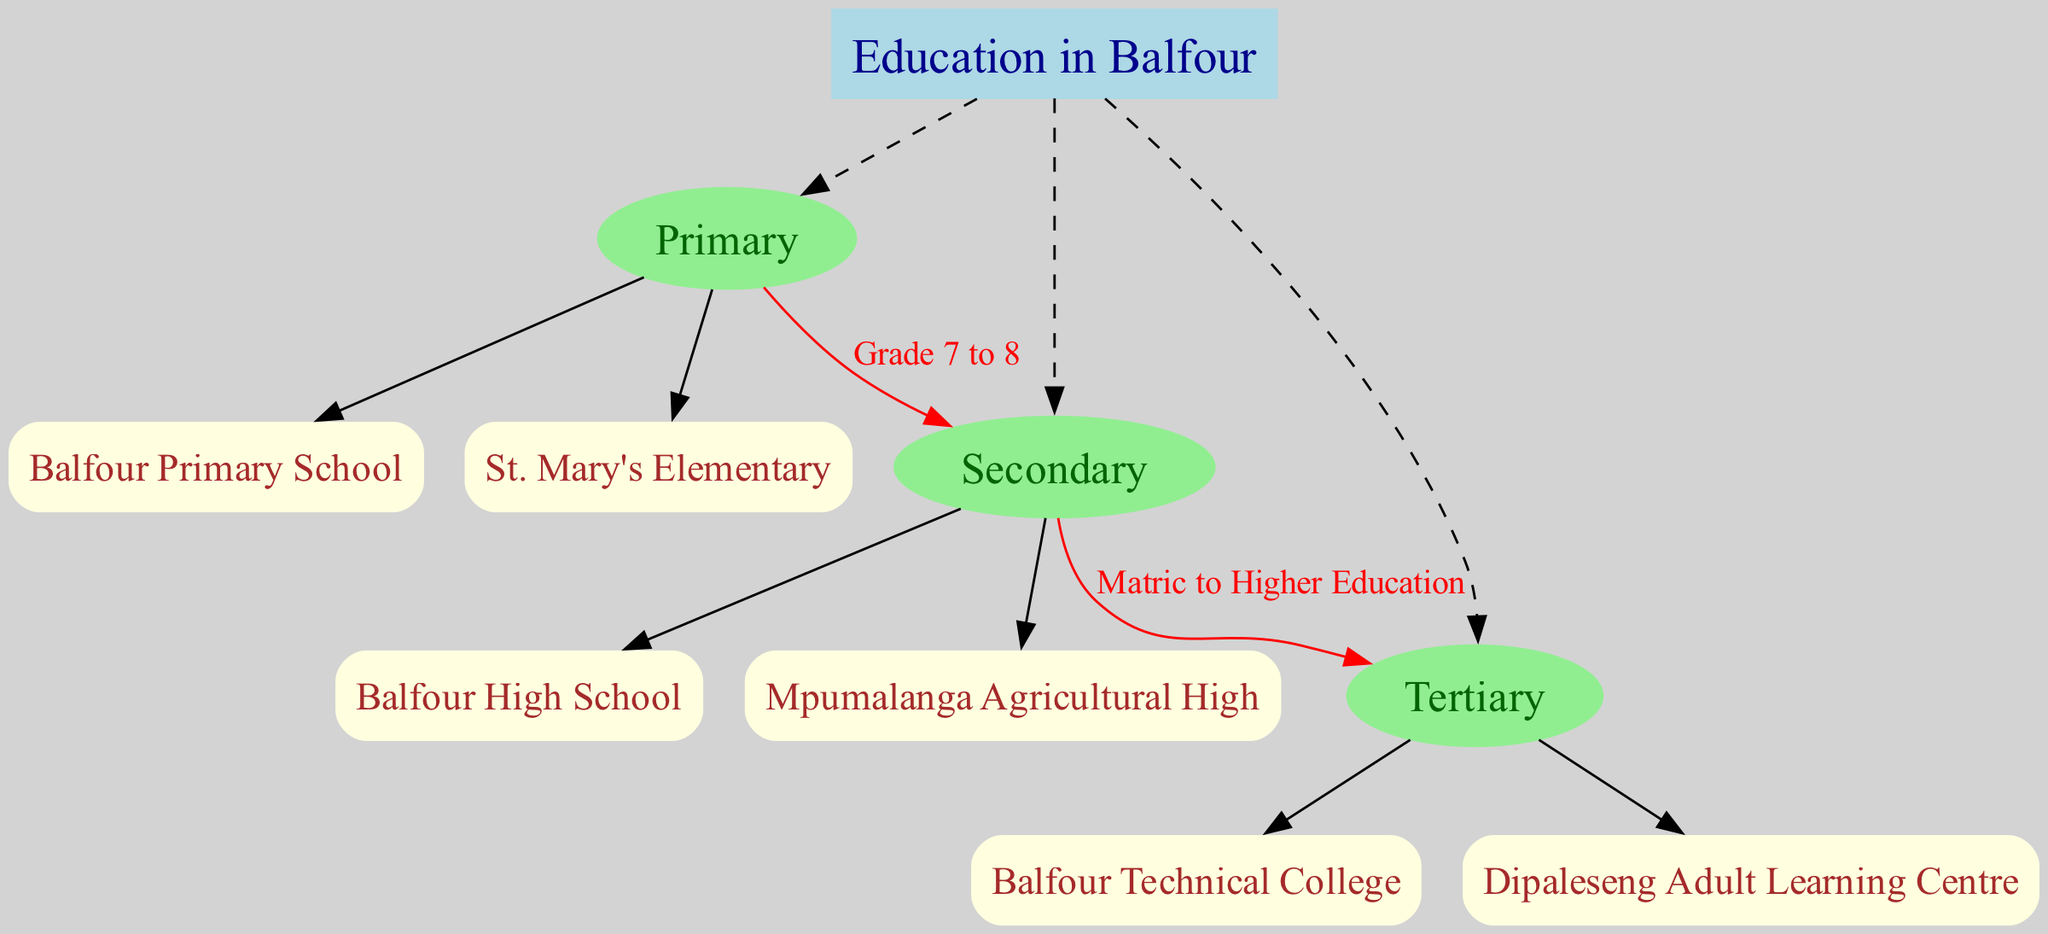What is the root node of the diagram? The diagram indicates that the root node is labeled "Education in Balfour," which represents the overarching theme of the hierarchy chart.
Answer: Education in Balfour How many primary institutions are listed? By examining the "Primary" level in the diagram, I see there are two institutions listed: "Balfour Primary School" and "St. Mary's Elementary." Therefore, the count is two.
Answer: 2 What label connects Primary to Secondary? Looking at the connection between the "Primary" and "Secondary" levels, the diagram shows a label with "Grade 7 to 8," indicating the transition from primary to secondary education.
Answer: Grade 7 to 8 Which institution is at the Secondary level? The diagram provides two institutions under the "Secondary" level: "Balfour High School" and "Mpumalanga Agricultural High." Therefore, either of these would be the answer.
Answer: Balfour High School What is the last level in the hierarchy chart? Analyzing the provided levels in the diagram, it is clear that the last level noted is "Tertiary," indicating institutions for higher education.
Answer: Tertiary What type of connection is shown from Secondary to Tertiary? The diagram specifies a connection from the "Secondary" level to the "Tertiary" level, labeled "Matric to Higher Education," indicating the progression path from secondary education to further education.
Answer: Matric to Higher Education How many institutions are there in total across all levels? By counting the institutions listed: 2 in Primary, 2 in Secondary, and 2 in Tertiary, we add these counts to find the total: 2 + 2 + 2 equals 6 institutions.
Answer: 6 Which educational institution serves adult learners? In the Tertiary level of the diagram, "Dipaleseng Adult Learning Centre" is explicitly mentioned, highlighting its focus on adult education.
Answer: Dipaleseng Adult Learning Centre What is the color of the nodes representing the levels? Each level node in the diagram is described as having a color of "light green." This color is consistent for the nodes associated with Primary, Secondary, and Tertiary levels.
Answer: Light green 